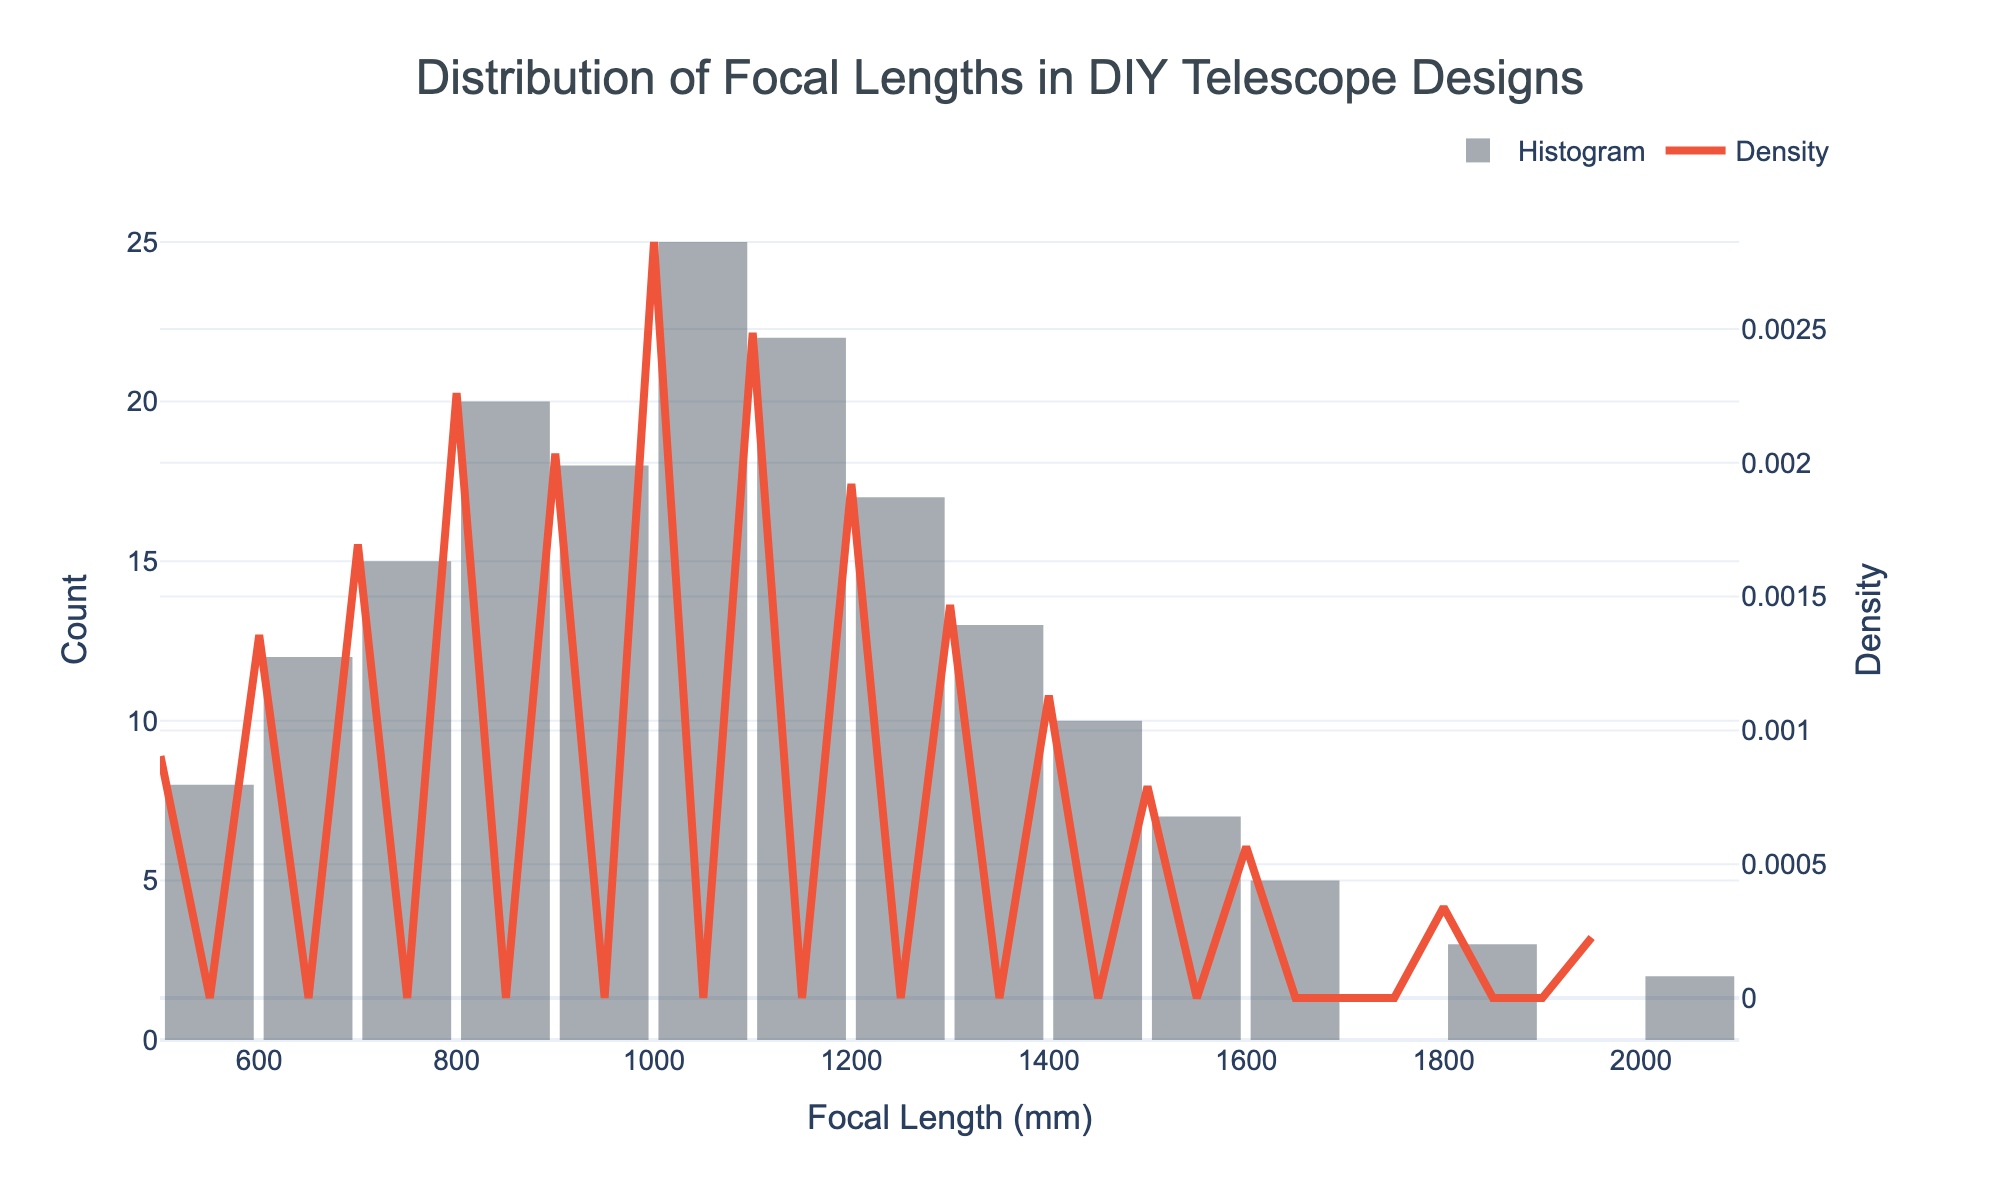what is the title of the figure? Look at the top of the histogram; the main label in large, bolded text is the title.
Answer: Distribution of Focal Lengths in DIY Telescope Designs What is the x-axis title? Check the horizontal label at the bottom of the figure; it denotes what the x-axis represents.
Answer: Focal Length (mm) Which focal length has the highest count? Identify the tallest bar in the histogram; it corresponds to the focal length with the highest count.
Answer: 1000 mm Which focal length has the lowest density? Look at the KDE curve (red line); the regions with the lowest height will indicate the smallest density.
Answer: 2000 mm Between which focal lengths does the first drop in density occur? Follow the KDE curve from left to right; the first noticeable decline in the KDE curve marks where the density drops.
Answer: Between 500 mm and 600 mm What is the general trend of the count as the focal lengths increase? Observe the histogram's bars from left to right to see whether they tend to increase, decrease, or remain constant.
Answer: Initially increases, peaks at 1000 mm, and then decreases Are there more focal lengths with counts above or below 1000 mm? Count the number of focal lengths above and below 1000 mm on the x-axis and compare them.
Answer: Below How does the density curve behave around the 800 mm focal length? Look at the KDE curve at the position where the 800 mm mark is to see if it peaks, dips, or remains flat.
Answer: Peaks At what range of focal lengths is the density highest? Identify the highest point on the KDE curve and note the corresponding range of focal lengths.
Answer: Around 1000 mm 